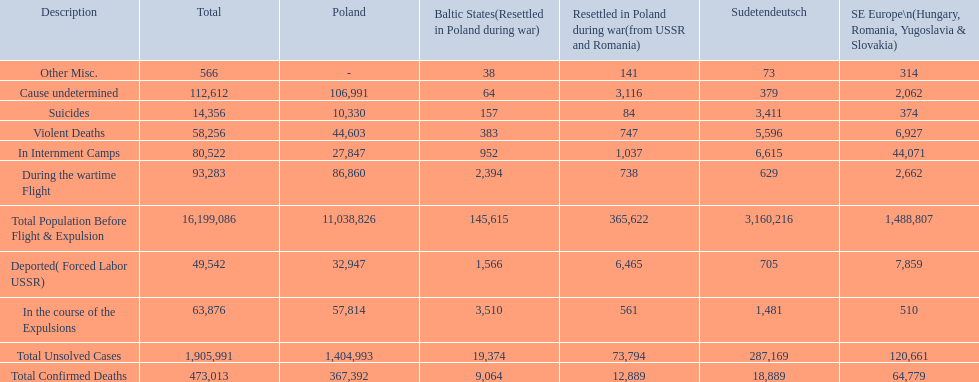What were all of the types of deaths? Violent Deaths, Suicides, Deported( Forced Labor USSR), In Internment Camps, During the wartime Flight, In the course of the Expulsions, Cause undetermined, Other Misc. And their totals in the baltic states? 383, 157, 1,566, 952, 2,394, 3,510, 64, 38. Were more deaths in the baltic states caused by undetermined causes or misc.? Cause undetermined. Parse the full table in json format. {'header': ['Description', 'Total', 'Poland', 'Baltic States(Resettled in Poland during war)', 'Resettled in Poland during war(from USSR and Romania)', 'Sudetendeutsch', 'SE Europe\\n(Hungary, Romania, Yugoslavia & Slovakia)'], 'rows': [['Other Misc.', '566', '-', '38', '141', '73', '314'], ['Cause undetermined', '112,612', '106,991', '64', '3,116', '379', '2,062'], ['Suicides', '14,356', '10,330', '157', '84', '3,411', '374'], ['Violent Deaths', '58,256', '44,603', '383', '747', '5,596', '6,927'], ['In Internment Camps', '80,522', '27,847', '952', '1,037', '6,615', '44,071'], ['During the wartime Flight', '93,283', '86,860', '2,394', '738', '629', '2,662'], ['Total Population Before Flight & Expulsion', '16,199,086', '11,038,826', '145,615', '365,622', '3,160,216', '1,488,807'], ['Deported( Forced Labor USSR)', '49,542', '32,947', '1,566', '6,465', '705', '7,859'], ['In the course of the Expulsions', '63,876', '57,814', '3,510', '561', '1,481', '510'], ['Total Unsolved Cases', '1,905,991', '1,404,993', '19,374', '73,794', '287,169', '120,661'], ['Total Confirmed Deaths', '473,013', '367,392', '9,064', '12,889', '18,889', '64,779']]} 